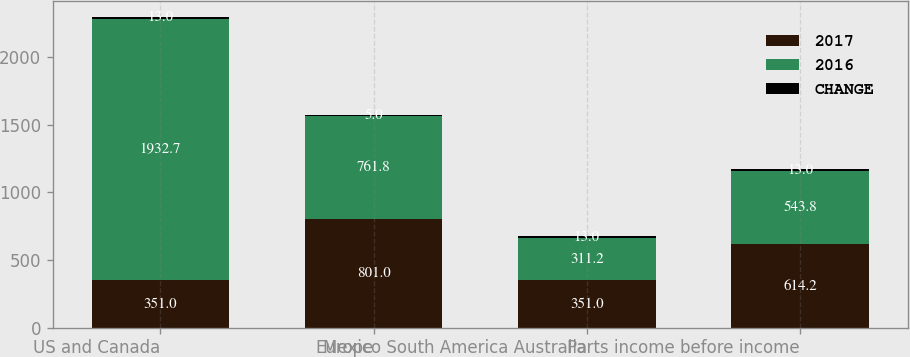Convert chart to OTSL. <chart><loc_0><loc_0><loc_500><loc_500><stacked_bar_chart><ecel><fcel>US and Canada<fcel>Europe<fcel>Mexico South America Australia<fcel>Parts income before income<nl><fcel>2017<fcel>351<fcel>801<fcel>351<fcel>614.2<nl><fcel>2016<fcel>1932.7<fcel>761.8<fcel>311.2<fcel>543.8<nl><fcel>CHANGE<fcel>13<fcel>5<fcel>13<fcel>13<nl></chart> 